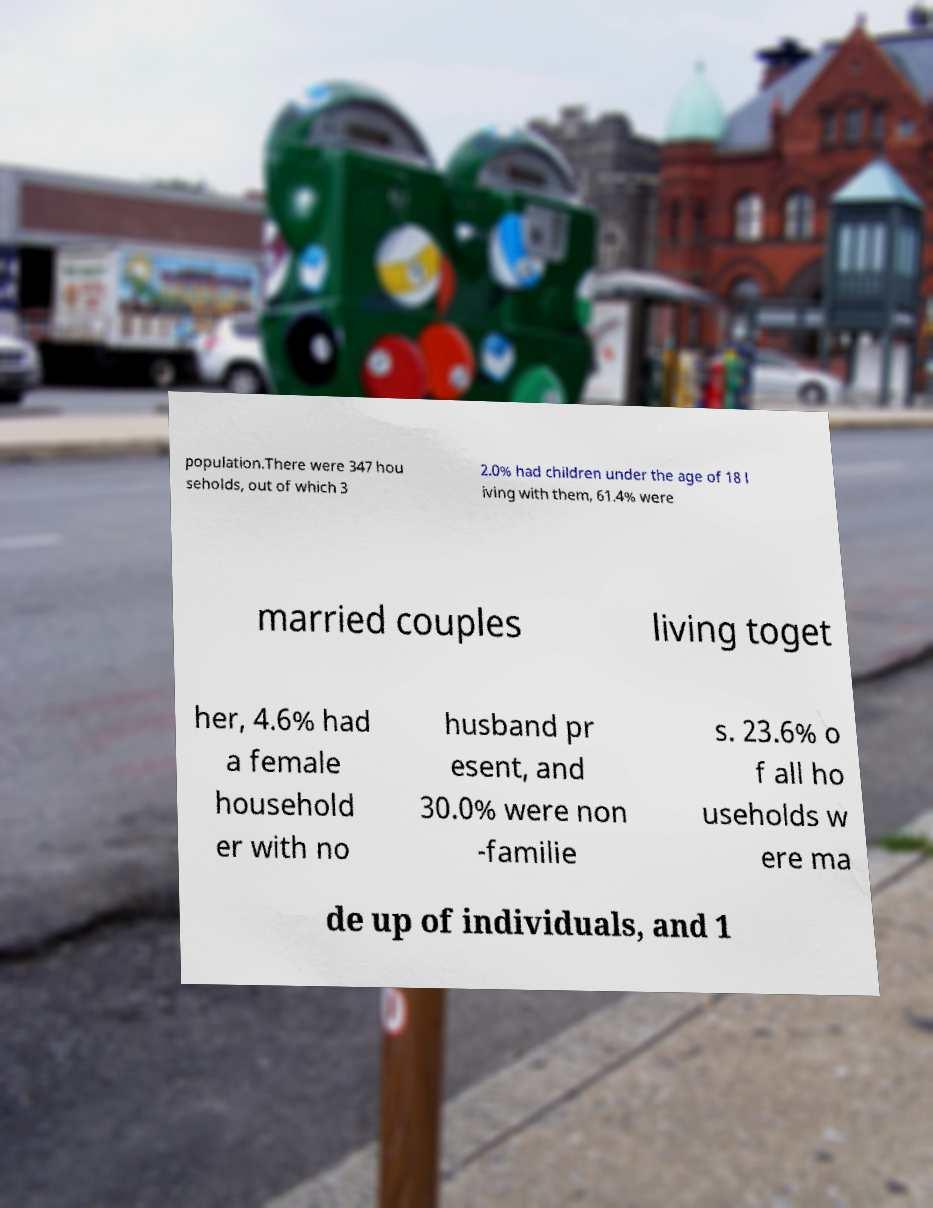I need the written content from this picture converted into text. Can you do that? population.There were 347 hou seholds, out of which 3 2.0% had children under the age of 18 l iving with them, 61.4% were married couples living toget her, 4.6% had a female household er with no husband pr esent, and 30.0% were non -familie s. 23.6% o f all ho useholds w ere ma de up of individuals, and 1 